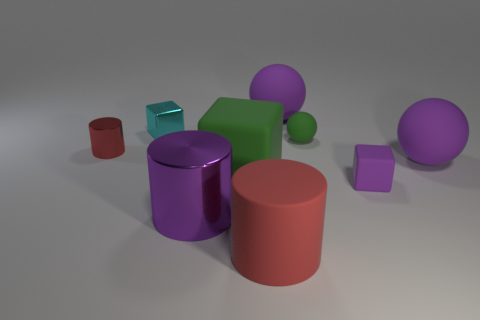Subtract all cylinders. How many objects are left? 6 Subtract all big metallic cylinders. How many cylinders are left? 2 Subtract all blue balls. How many red cubes are left? 0 Subtract all purple balls. How many balls are left? 1 Subtract 0 gray cylinders. How many objects are left? 9 Subtract all cyan cubes. Subtract all yellow cylinders. How many cubes are left? 2 Subtract all large purple metal cylinders. Subtract all small balls. How many objects are left? 7 Add 2 tiny red things. How many tiny red things are left? 3 Add 4 matte blocks. How many matte blocks exist? 6 